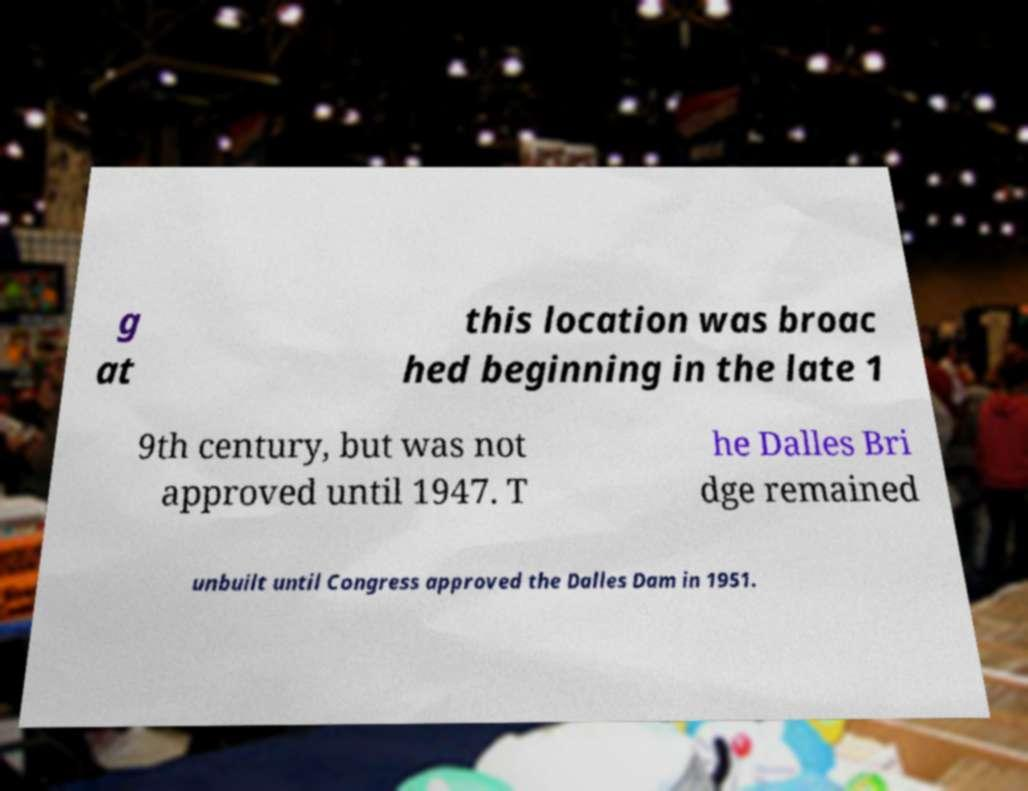There's text embedded in this image that I need extracted. Can you transcribe it verbatim? g at this location was broac hed beginning in the late 1 9th century, but was not approved until 1947. T he Dalles Bri dge remained unbuilt until Congress approved the Dalles Dam in 1951. 